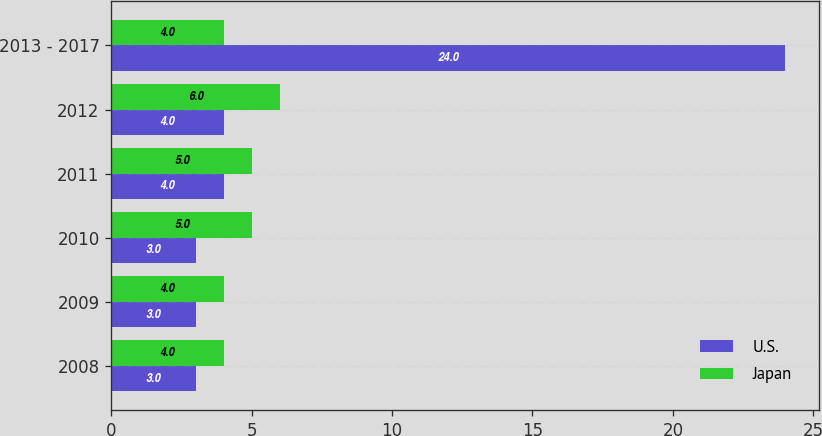Convert chart to OTSL. <chart><loc_0><loc_0><loc_500><loc_500><stacked_bar_chart><ecel><fcel>2008<fcel>2009<fcel>2010<fcel>2011<fcel>2012<fcel>2013 - 2017<nl><fcel>U.S.<fcel>3<fcel>3<fcel>3<fcel>4<fcel>4<fcel>24<nl><fcel>Japan<fcel>4<fcel>4<fcel>5<fcel>5<fcel>6<fcel>4<nl></chart> 